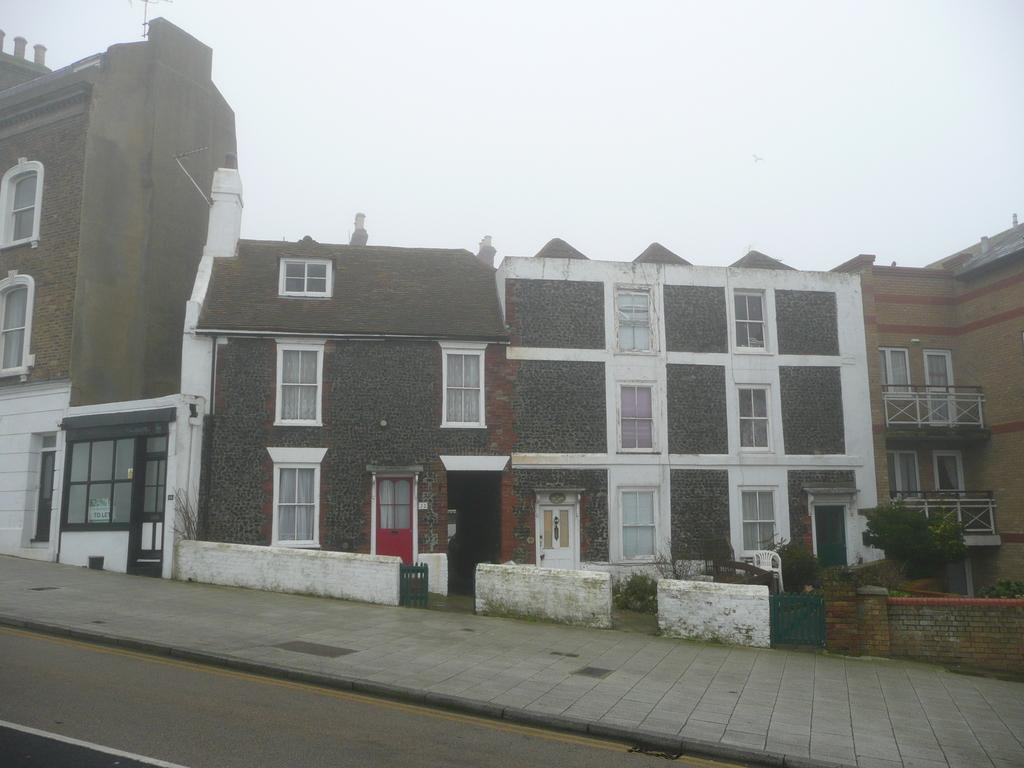What type of structures can be seen in the image? There are buildings in the image. What architectural elements are visible in the image? There are walls visible in the image. What type of vegetation is present in the image? There are plants in the image. What type of surface can be seen in the image? There is a path in the image. What can be seen in the background of the image? The sky is visible in the background of the image. What type of brick pattern can be seen on the coach in the image? There is no coach present in the image, and therefore no brick pattern can be observed. What type of print is visible on the plants in the image? The plants in the image do not have any prints; they are natural vegetation. 